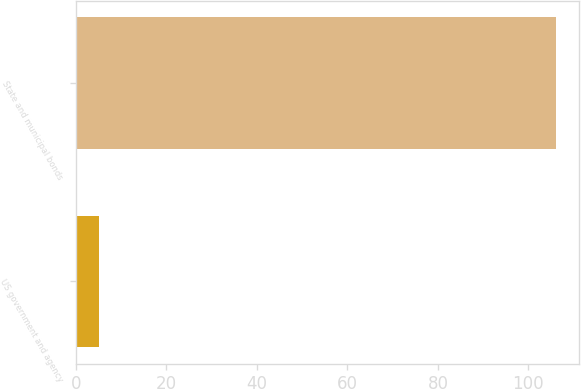Convert chart to OTSL. <chart><loc_0><loc_0><loc_500><loc_500><bar_chart><fcel>US government and agency<fcel>State and municipal bonds<nl><fcel>5<fcel>106<nl></chart> 